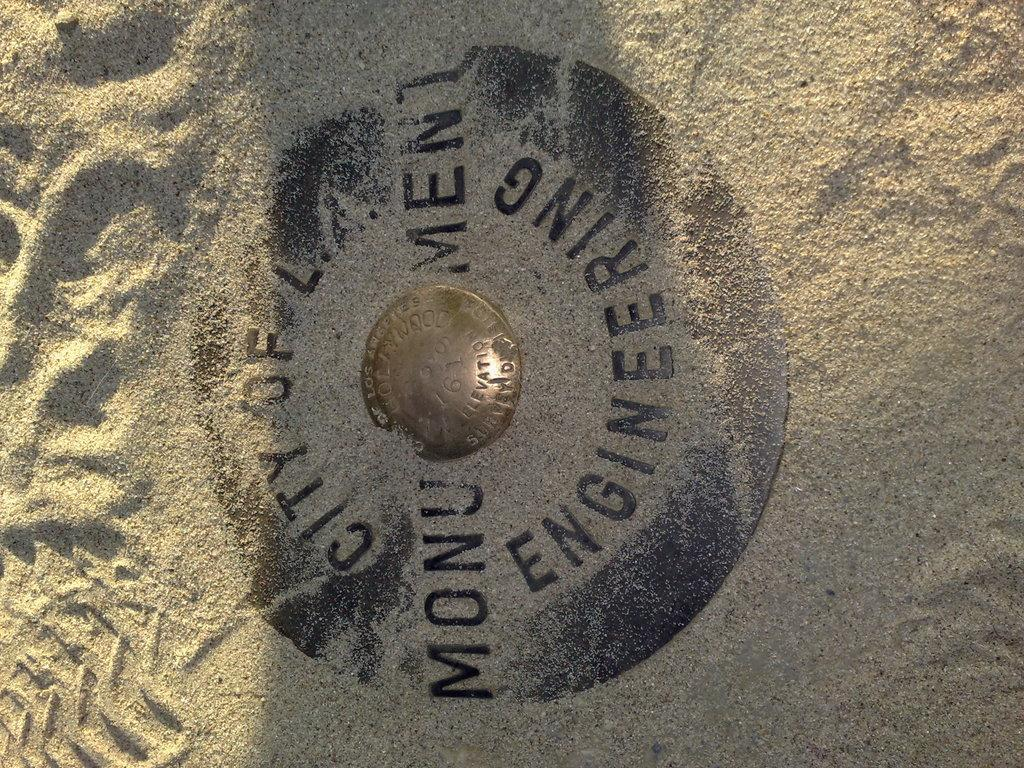<image>
Share a concise interpretation of the image provided. a gold coin in sand with the words 'city of l. monu ment enginering' 